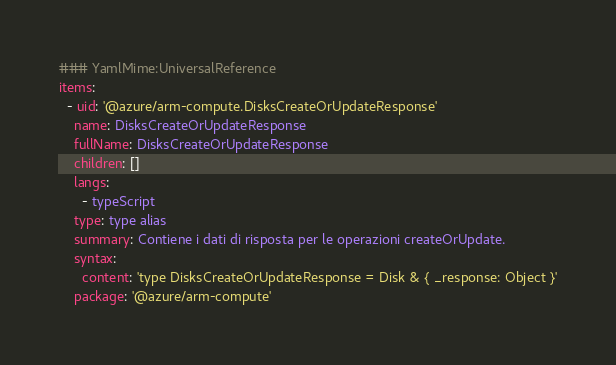Convert code to text. <code><loc_0><loc_0><loc_500><loc_500><_YAML_>### YamlMime:UniversalReference
items:
  - uid: '@azure/arm-compute.DisksCreateOrUpdateResponse'
    name: DisksCreateOrUpdateResponse
    fullName: DisksCreateOrUpdateResponse
    children: []
    langs:
      - typeScript
    type: type alias
    summary: Contiene i dati di risposta per le operazioni createOrUpdate.
    syntax:
      content: 'type DisksCreateOrUpdateResponse = Disk & { _response: Object }'
    package: '@azure/arm-compute'</code> 